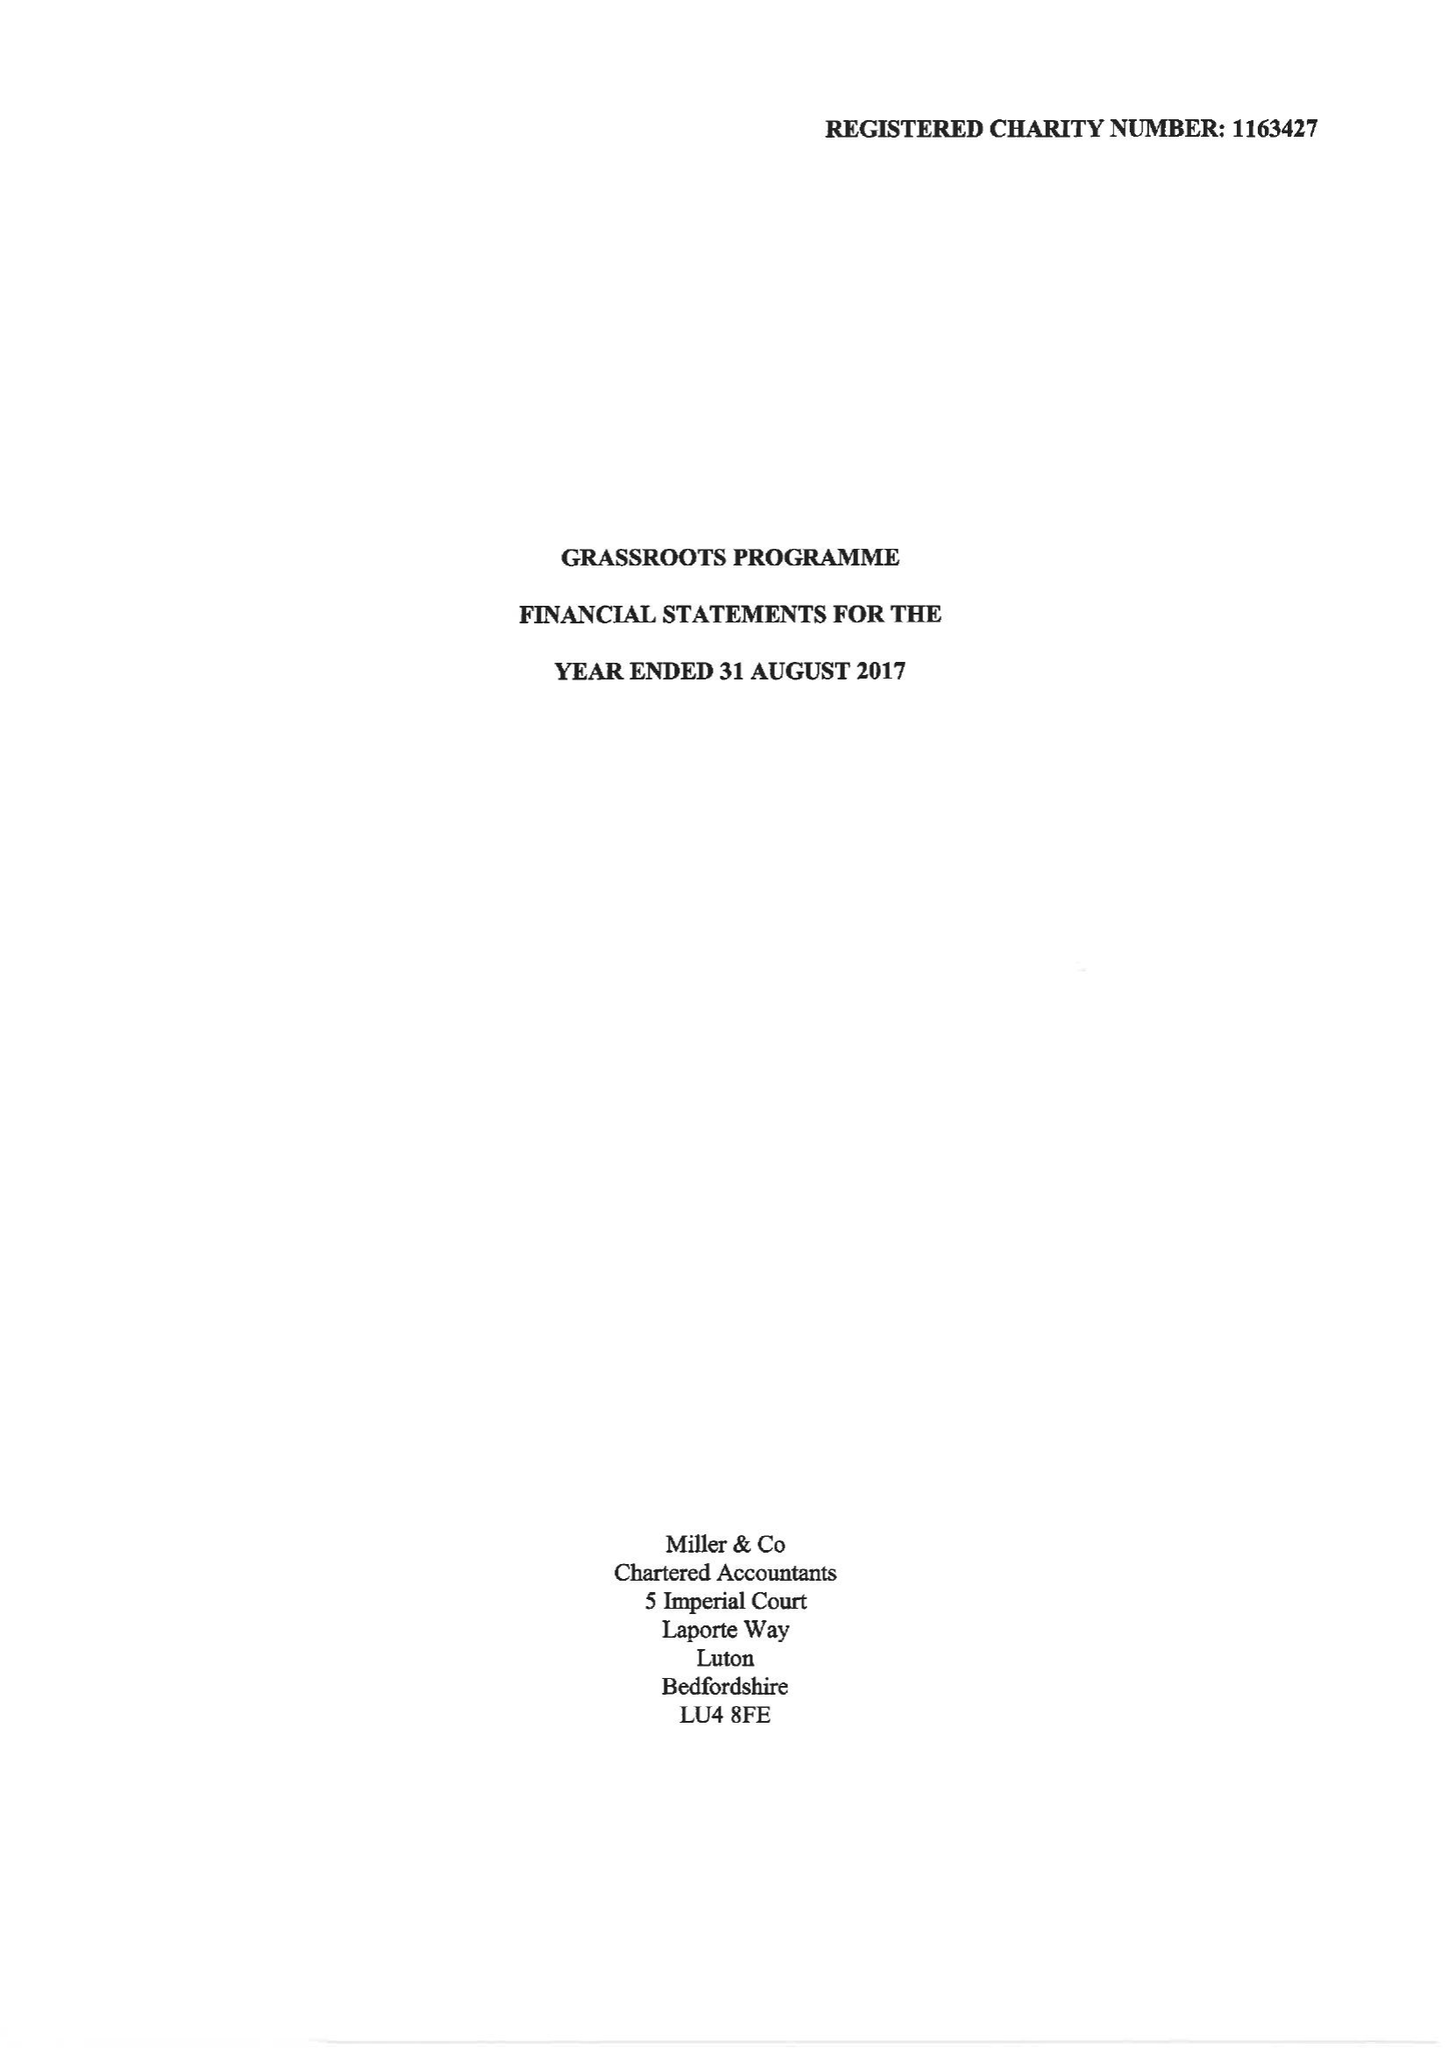What is the value for the charity_name?
Answer the question using a single word or phrase. Grassroots Programme 